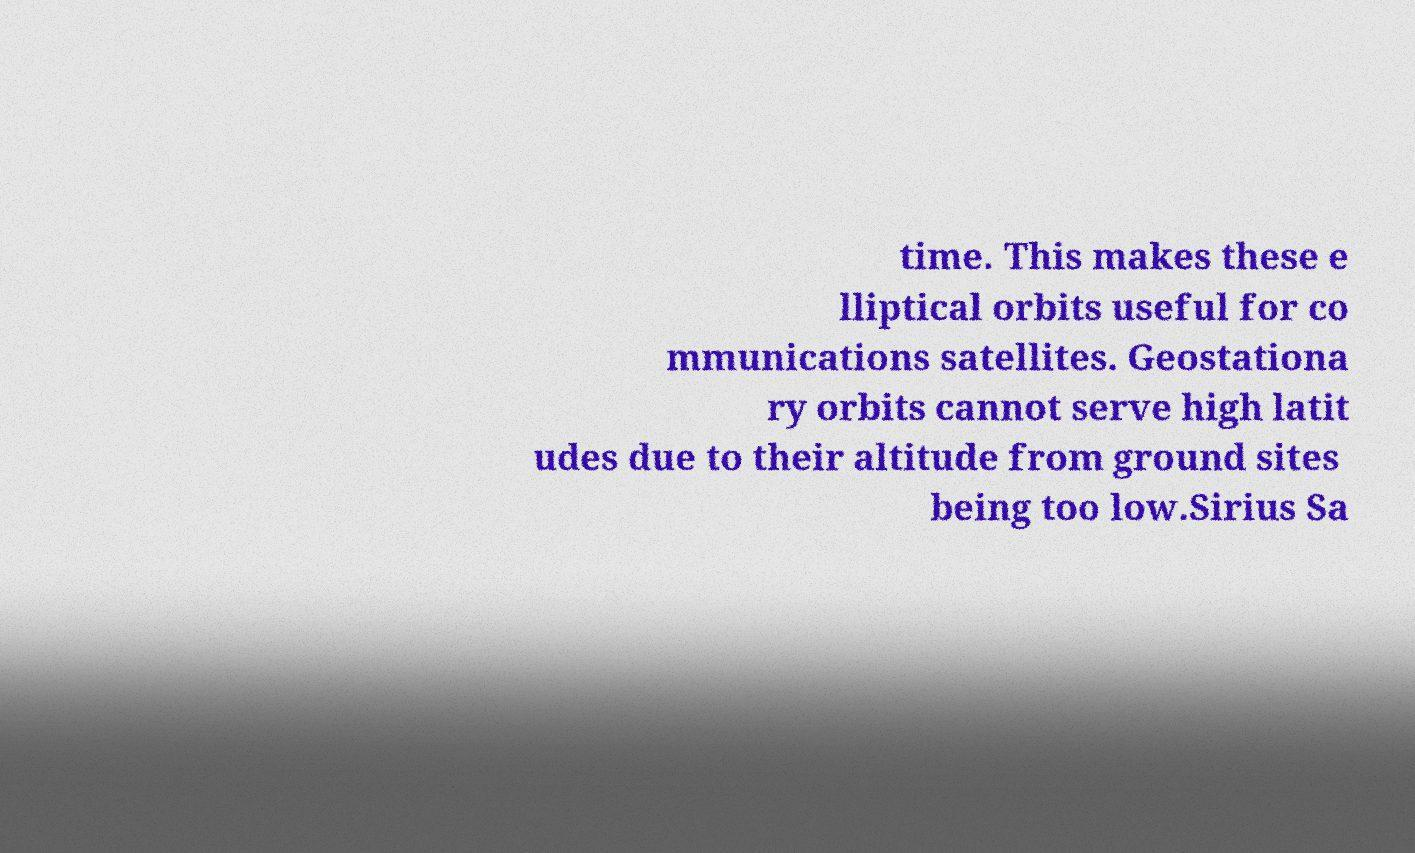Please identify and transcribe the text found in this image. time. This makes these e lliptical orbits useful for co mmunications satellites. Geostationa ry orbits cannot serve high latit udes due to their altitude from ground sites being too low.Sirius Sa 